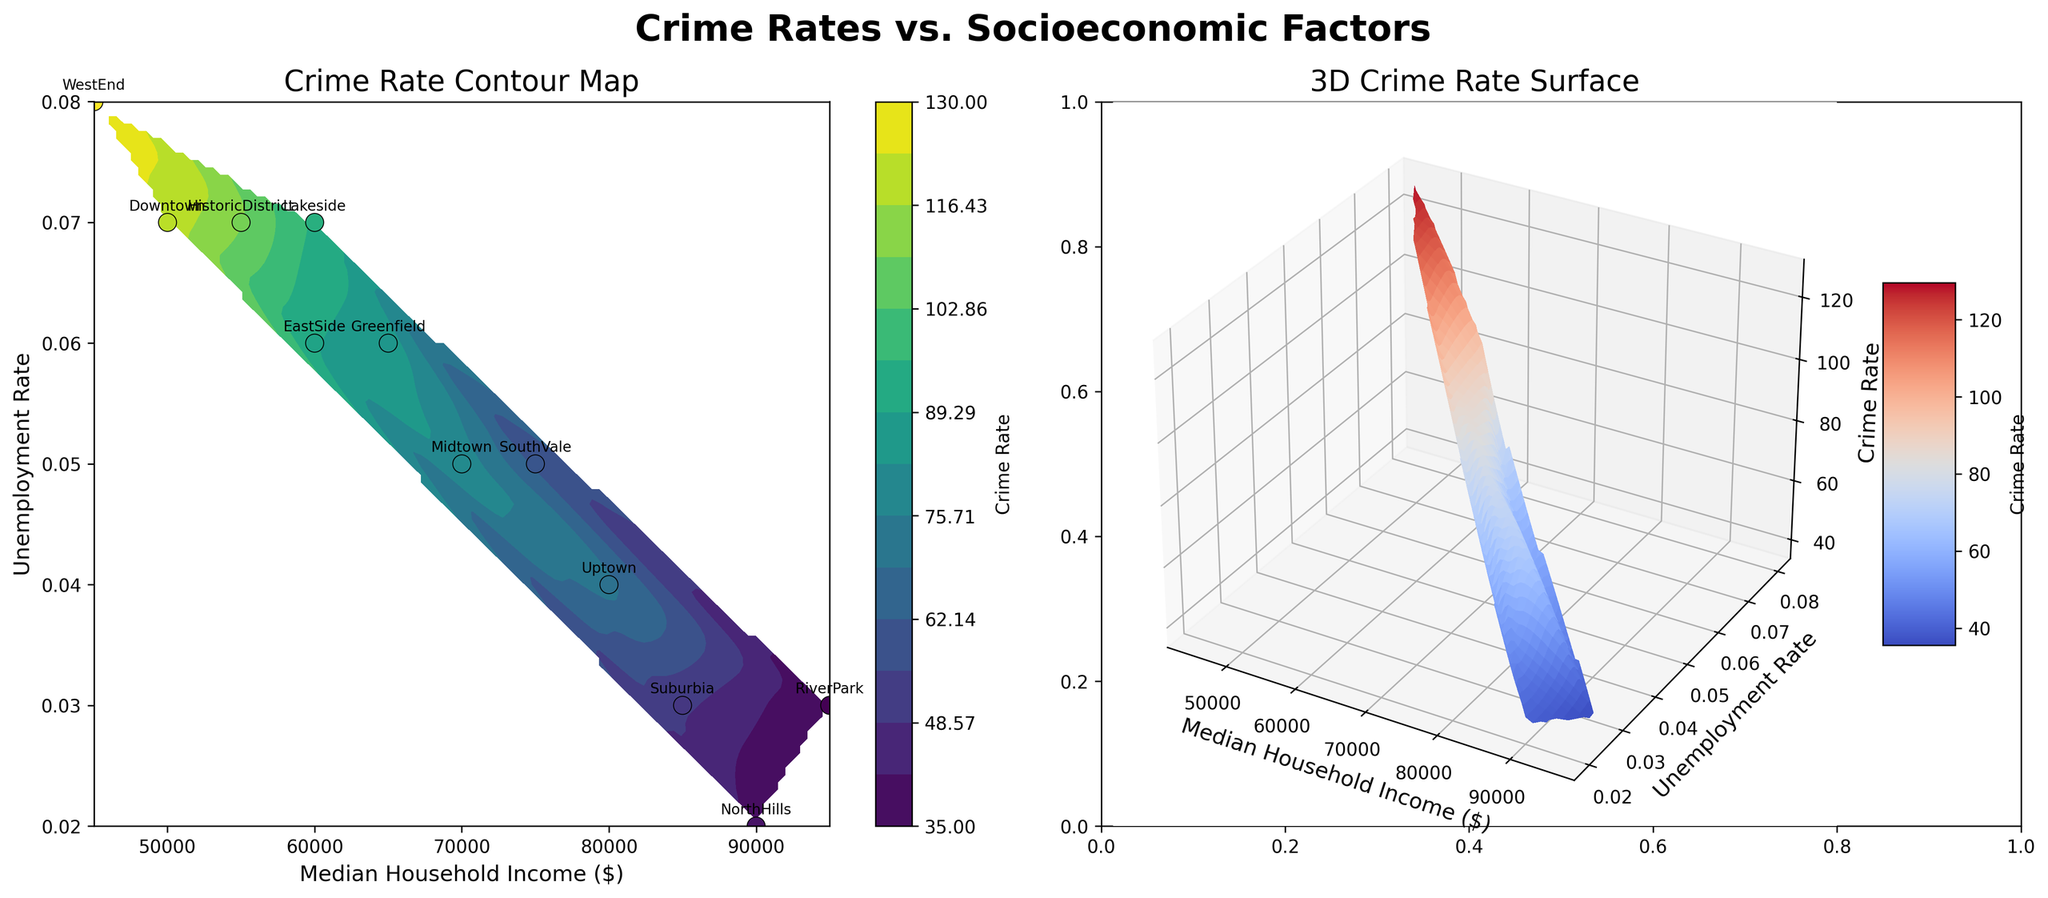What is the title of the contour plot on the left subplot? The title of the contour plot is located at the top of the left subplot. It reads "Crime Rate Contour Map."
Answer: Crime Rate Contour Map Which neighborhood has the highest Crime Rate, and what is that rate? By looking at the scatter plot with annotated neighborhood names, the neighborhood with the highest Crime Rate has a large number associated with it. The annotation for WestEnd shows 130, which is the highest rate.
Answer: WestEnd, 130 How does the Crime Rate change with increasing Median Household Income? On the contour plot, as you move from left to right (which corresponds to increasing Median Household Income), the color on the contour plot generally transitions from darker to lighter shades. This indicates a decreasing Crime Rate with increasing income.
Answer: Decreases What is the general trend of Crime Rate with respect to Unemployment Rate in the contour plot? On the left plot, as you move upward (which indicates increasing Unemployment Rate), the color gradient generally moves toward darker shades, indicating high Crime Rates.
Answer: Increases Which neighborhood has the lowest Unemployment Rate, and what is its corresponding Crime Rate? By examining the annotated scatter plot, NorthHills has the lowest Unemployment Rate (0.02). The associated color indicates a low Crime Rate, supported by the Crime Rate value of 40.
Answer: NorthHills, 40 Which neighborhood has a Median Household Income of around $60,000, and how does its Crime Rate compare to its neighbors? By looking at the scatter plot, EastSide has a Median Household Income of around $60,000. Its Crime Rate (90) is lower compared to Lakeside (95) but higher compared to Greenfield (85).
Answer: EastSide; higher than Greenfield, lower than Lakeside What is the Crime Rate for neighborhood Suburbia, and how does it compare with the nonprofit-income neighborhood? Suburbia has a Crime Rate of 50, which can be compared with RiverPark which has a Crime Rate of 35. Therefore, Suburbia has a higher Crime Rate than RiverPark.
Answer: 50; higher If we consider neighborhoods with Median Household Income above $80,000, how do their Crime Rates compare to those below $60,000? The neighborhoods with income above $80,000 (Uptown, Suburbia, NorthHills, RiverPark) generally have lower Crime Rates ranging from 35 to 70. In contrast, neighborhoods with income below $60,000 (Downtown, WestEnd) show higher Crime Rates ranging from 120 to 130.
Answer: Lower On the 3D surface plot, what general trend do you see in the z-axis (Crime Rate) as you increase x (Median Household Income)? On the 3D surface plot, as x (Median Household Income) increases, the surface tends to dip downward, indicating that Crime Rates decrease.
Answer: Decreases How does the contour plot visually differentiate between neighborhoods with high and low Crime Rates? The contour plot utilizes a color gradient where dark shades represent high Crime Rates and light shades indicate low Crime Rates. This visual differentiation helps to easily identify the Crime Rate for any given neighborhood.
Answer: Color gradient (dark for high, light for low) 